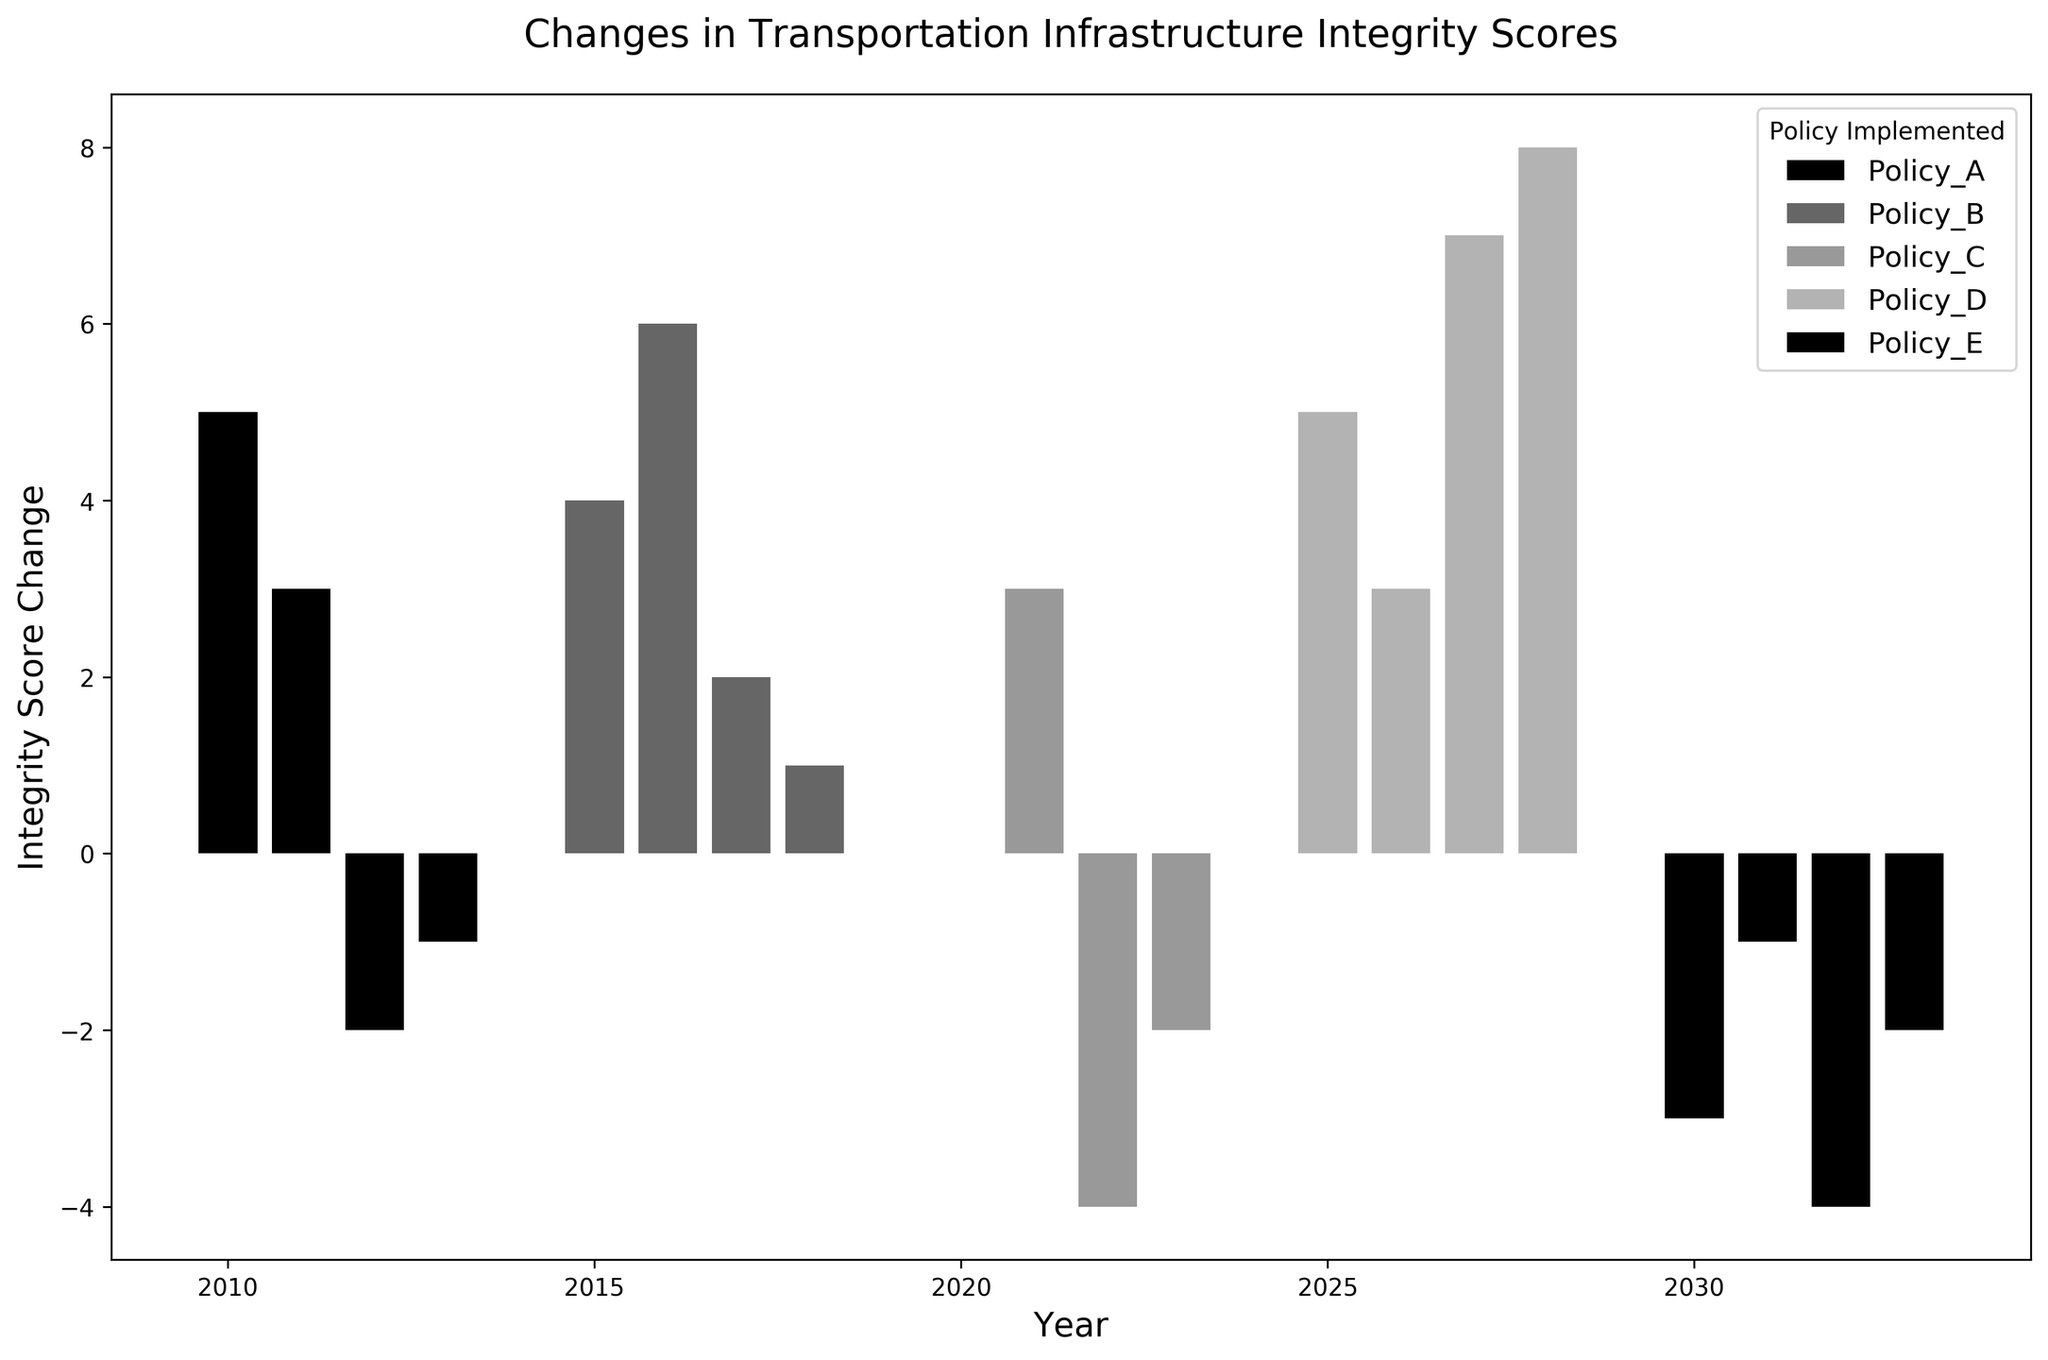What policy had the highest positive integrity score change in a single year? To find the policy with the highest positive integrity score change in a single year, look for the tallest bar above the zero line. The highest bar represents Policy_D in 2028 with an integrity score change of 8.
Answer: Policy_D Which policy experienced the most negative integrity score change, and in which year? To determine this, look for the bar that extends the furthest below the zero line. The bar with the lowest value is for Policy_C in 2022, with an integrity score change of -4.
Answer: Policy_C, 2022 Which policy displayed consistent improvements in the integrity scores over multiple consecutive years? Look for policies where the bars are consistently above the zero line across multiple years. Policy_D shows consistent improvement from 2025 to 2028.
Answer: Policy_D How many policies show both positive and negative integrity score changes over the years? Check each policy's set of bars to see if they have both positive and negative values. Policies A and C show both positive and negative changes.
Answer: 2 What is the total integrity score change for Policy_B over the years? Sum the integrity score changes for Policy_B. The changes are 4 + 6 + 2 + 1 = 13.
Answer: 13 Which year had the greatest number of policies showing negative integrity score changes? Identify the years with negative bars and count the number of policies for each year. 2012 (Policy_A), 2022 (Policy_C), 2030 (Policy_E), 2032 (Policy_E), and 2033 (Policy_E) show negative changes in policy integrity scores. 2032 has the highest number.
Answer: 2032 What is the average integrity score change for Policy_A in the years listed? The integrity score changes for Policy_A are 5, 3, -2, and -1. Sum these values (5 + 3 + -2 + -1 = 5) and divide by the number of years (4). The average is 5/4 = 1.25.
Answer: 1.25 Which policy had no negative integrity score changes during the period displayed? Observe each policy's bar heights, and identify the one without bars below the zero line. Policy_B and Policy_D have no negative integrity score changes.
Answer: Policy_B, Policy_D Compare the overall trend of integrity scores before and after 2020. What do you observe? Before 2020, Policies A and B generally have more positive changes than negative. After 2020, while Policy_D has positive scores, Policies C and E exhibit more negative changes.
Answer: More negative changes overall post-2020 In which year did Policy_E experience the least negative integrity score change? The least negative score for Policy_E would be the bar closest to zero but still below it. This occurred in 2031 with a change of -1.
Answer: 2031 